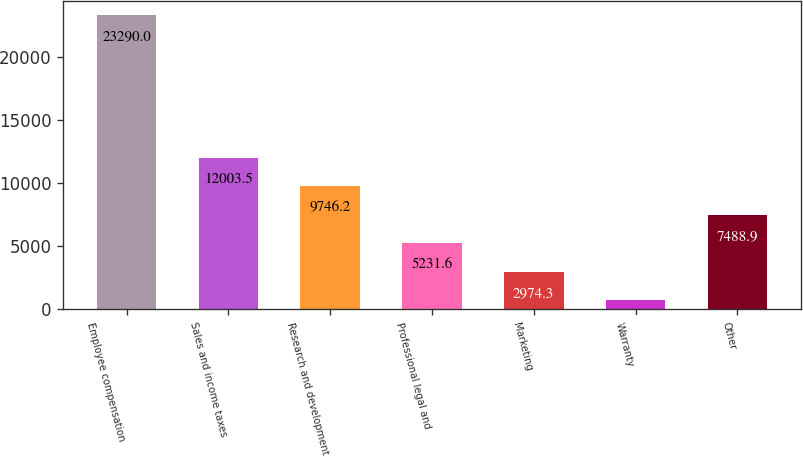Convert chart to OTSL. <chart><loc_0><loc_0><loc_500><loc_500><bar_chart><fcel>Employee compensation<fcel>Sales and income taxes<fcel>Research and development<fcel>Professional legal and<fcel>Marketing<fcel>Warranty<fcel>Other<nl><fcel>23290<fcel>12003.5<fcel>9746.2<fcel>5231.6<fcel>2974.3<fcel>717<fcel>7488.9<nl></chart> 